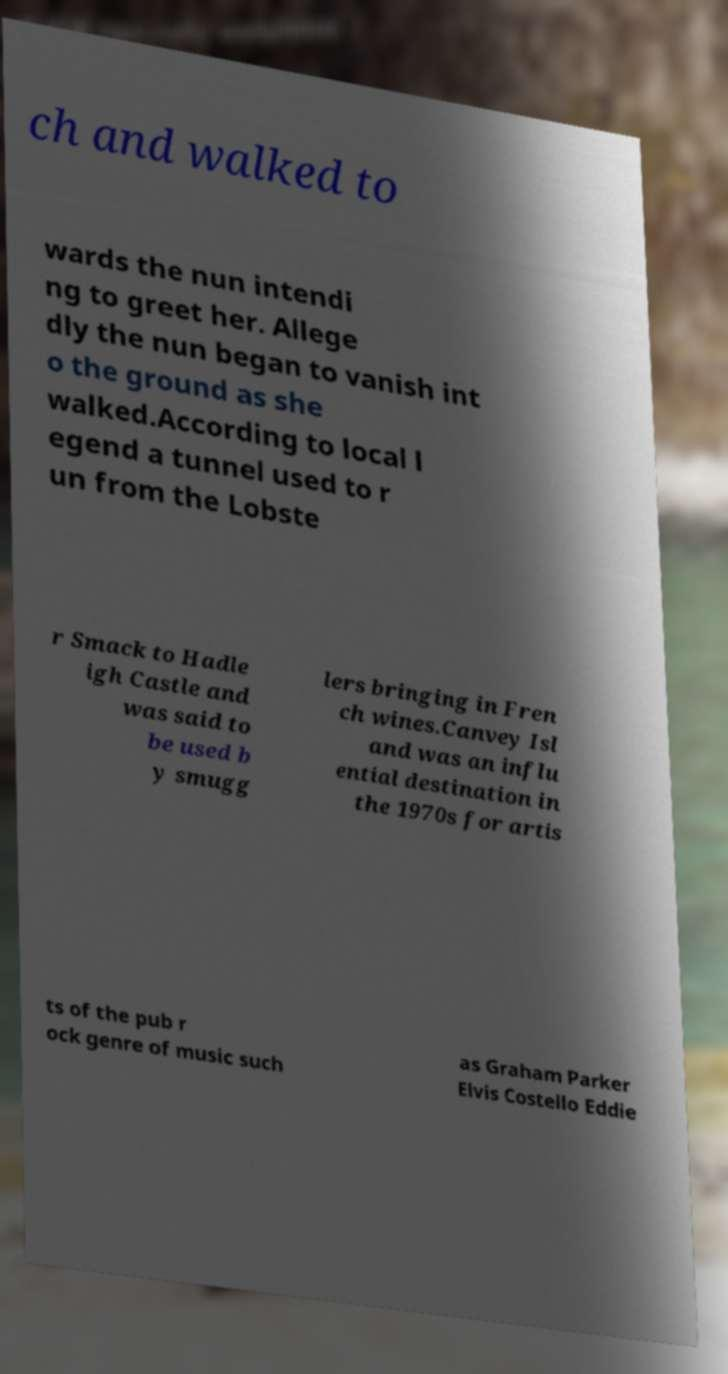For documentation purposes, I need the text within this image transcribed. Could you provide that? ch and walked to wards the nun intendi ng to greet her. Allege dly the nun began to vanish int o the ground as she walked.According to local l egend a tunnel used to r un from the Lobste r Smack to Hadle igh Castle and was said to be used b y smugg lers bringing in Fren ch wines.Canvey Isl and was an influ ential destination in the 1970s for artis ts of the pub r ock genre of music such as Graham Parker Elvis Costello Eddie 